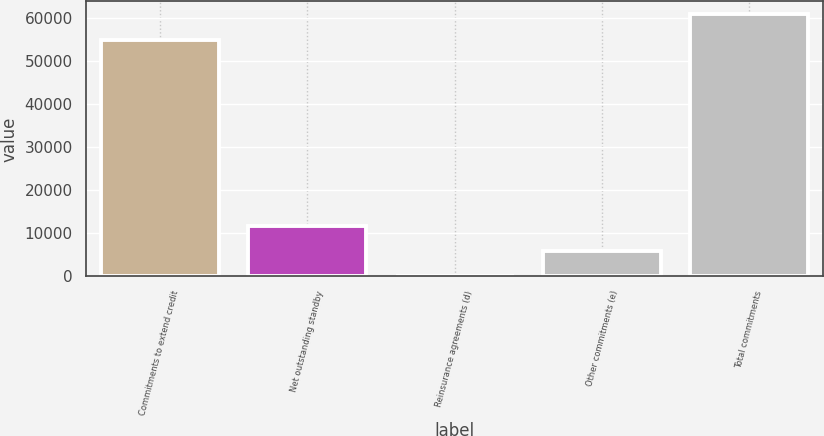Convert chart to OTSL. <chart><loc_0><loc_0><loc_500><loc_500><bar_chart><fcel>Commitments to extend credit<fcel>Net outstanding standby<fcel>Reinsurance agreements (d)<fcel>Other commitments (e)<fcel>Total commitments<nl><fcel>55045<fcel>11733.4<fcel>24<fcel>5878.7<fcel>60899.7<nl></chart> 